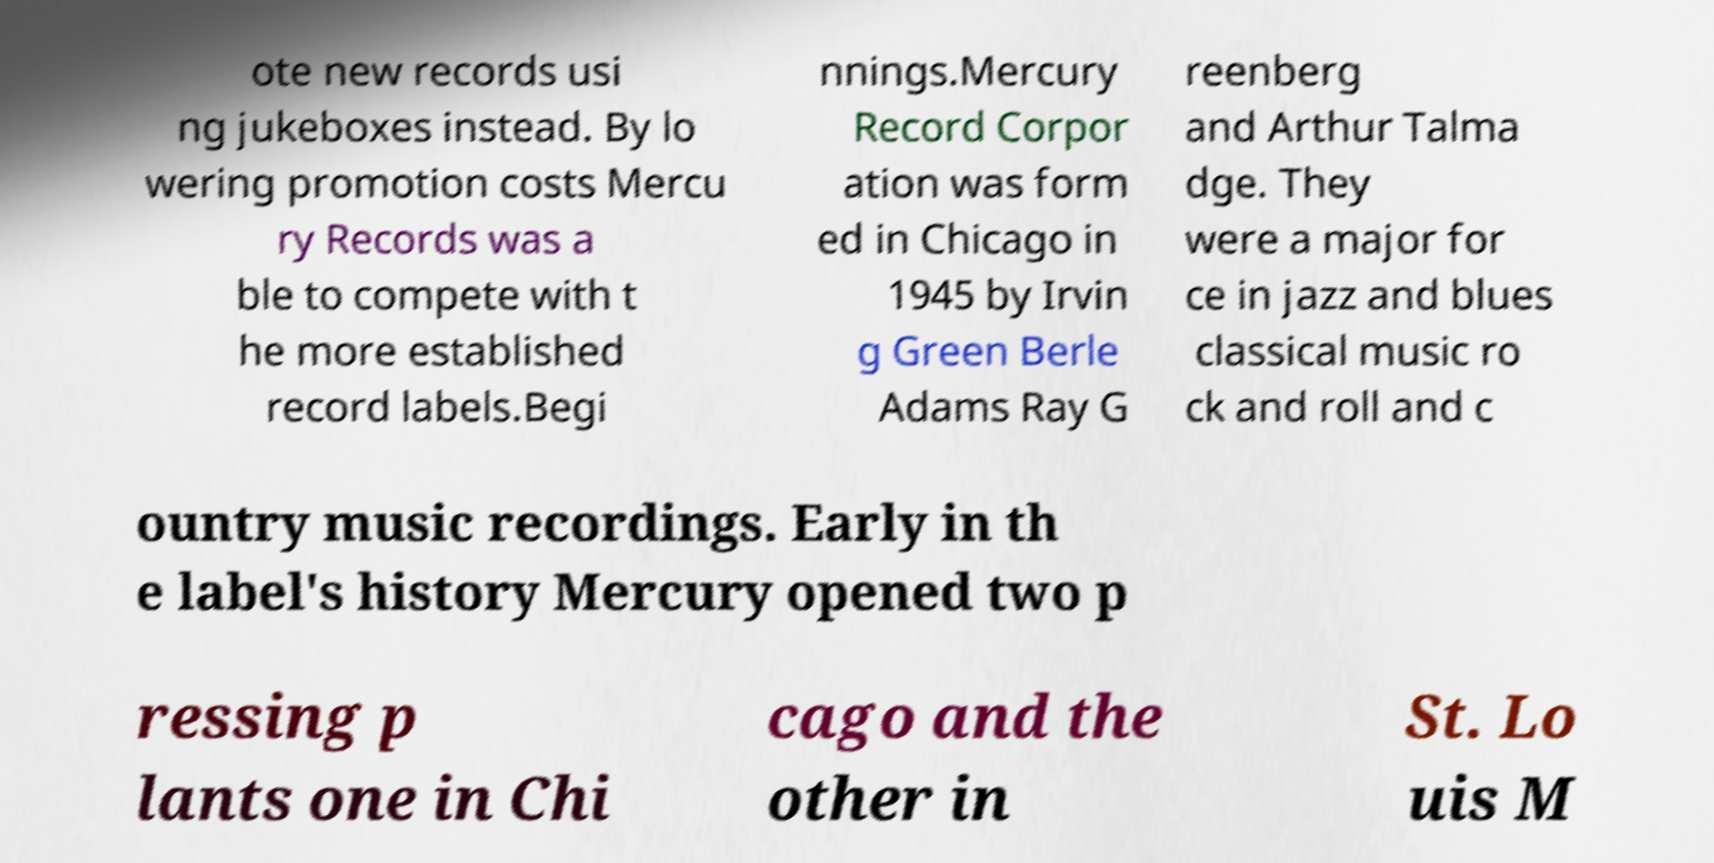Can you read and provide the text displayed in the image?This photo seems to have some interesting text. Can you extract and type it out for me? ote new records usi ng jukeboxes instead. By lo wering promotion costs Mercu ry Records was a ble to compete with t he more established record labels.Begi nnings.Mercury Record Corpor ation was form ed in Chicago in 1945 by Irvin g Green Berle Adams Ray G reenberg and Arthur Talma dge. They were a major for ce in jazz and blues classical music ro ck and roll and c ountry music recordings. Early in th e label's history Mercury opened two p ressing p lants one in Chi cago and the other in St. Lo uis M 